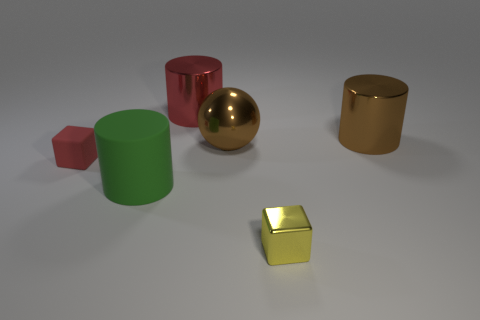Subtract all big metal cylinders. How many cylinders are left? 1 Add 2 tiny green metallic balls. How many objects exist? 8 Subtract all yellow blocks. How many blocks are left? 1 Subtract all blocks. How many objects are left? 4 Subtract all small cyan metal cylinders. Subtract all small rubber objects. How many objects are left? 5 Add 1 small yellow shiny objects. How many small yellow shiny objects are left? 2 Add 1 large red metallic cylinders. How many large red metallic cylinders exist? 2 Subtract 1 red cylinders. How many objects are left? 5 Subtract 1 balls. How many balls are left? 0 Subtract all cyan cylinders. Subtract all green cubes. How many cylinders are left? 3 